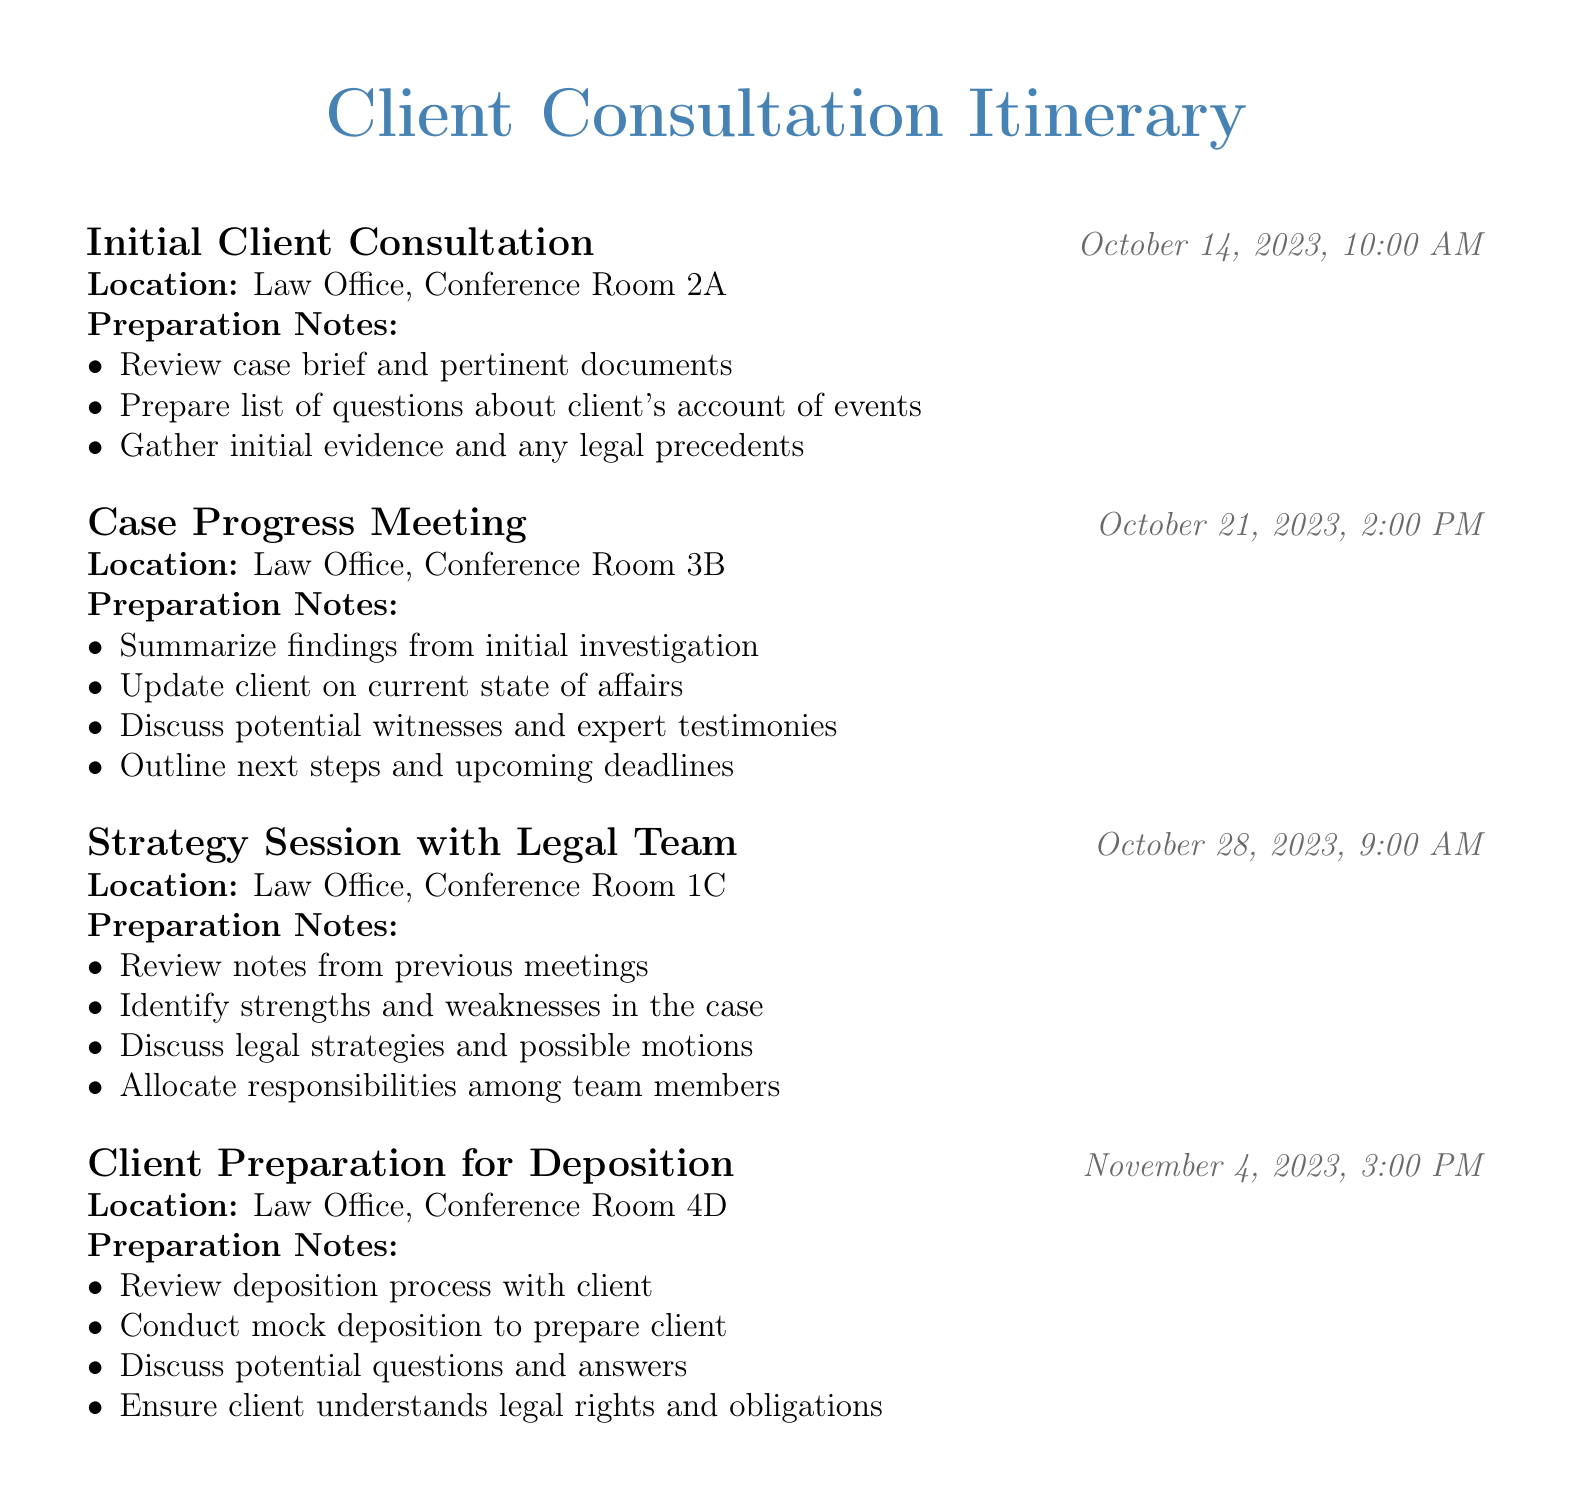What is the date of the Initial Client Consultation? The date of the Initial Client Consultation is directly stated in the document under the meeting entry section.
Answer: October 14, 2023 What is the time for the Case Progress Meeting? The time for the Case Progress Meeting is indicated in the document next to the corresponding meeting title.
Answer: 2:00 PM Where will the Strategy Session with Legal Team take place? The location for the Strategy Session with Legal Team is specified in the meeting entry section of the document.
Answer: Law Office, Conference Room 1C What preparation notes are required for the Client Preparation for Deposition? The preparation notes for the Client Preparation for Deposition include multiple items listed in the document.
Answer: Review deposition process with client, conduct mock deposition to prepare client, discuss potential questions and answers, ensure client understands legal rights and obligations How many meetings are scheduled in total? The total number of meetings can be counted from the meeting entries listed in the document.
Answer: 4 What are the main topics discussed in the Case Progress Meeting? The main topics are outlined in the preparation notes section for the Case Progress Meeting.
Answer: Summarize findings, update client, discuss witnesses, outline next steps 